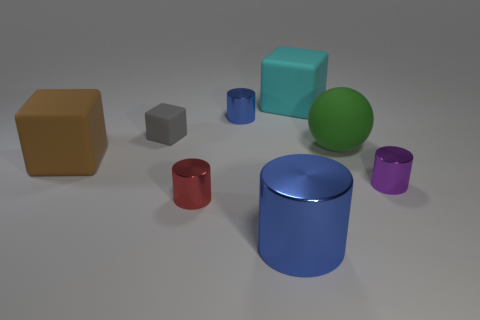How many blue cylinders must be subtracted to get 1 blue cylinders? 1 Subtract all red cylinders. How many cylinders are left? 3 Subtract all purple cylinders. How many cylinders are left? 3 Subtract all spheres. How many objects are left? 7 Subtract 1 balls. How many balls are left? 0 Subtract all purple blocks. How many gray balls are left? 0 Subtract all small gray cubes. Subtract all large blue cylinders. How many objects are left? 6 Add 4 big things. How many big things are left? 8 Add 7 yellow rubber things. How many yellow rubber things exist? 7 Add 1 small blue rubber cubes. How many objects exist? 9 